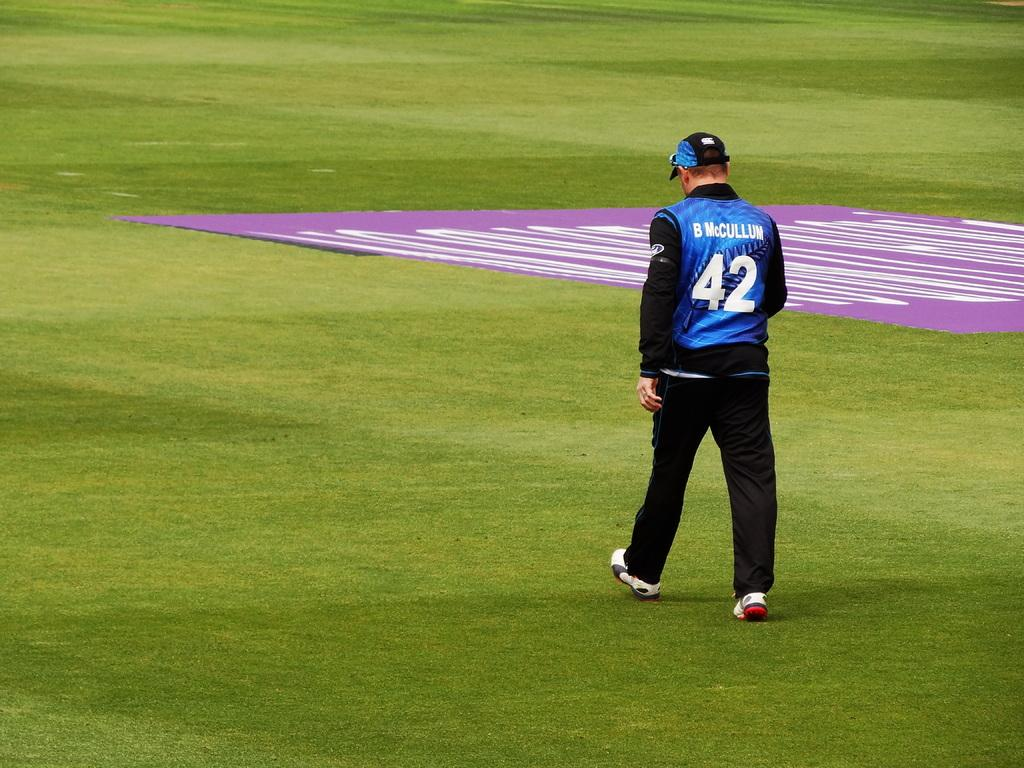<image>
Describe the image concisely. Player wearing the number 42 on a grass field. 